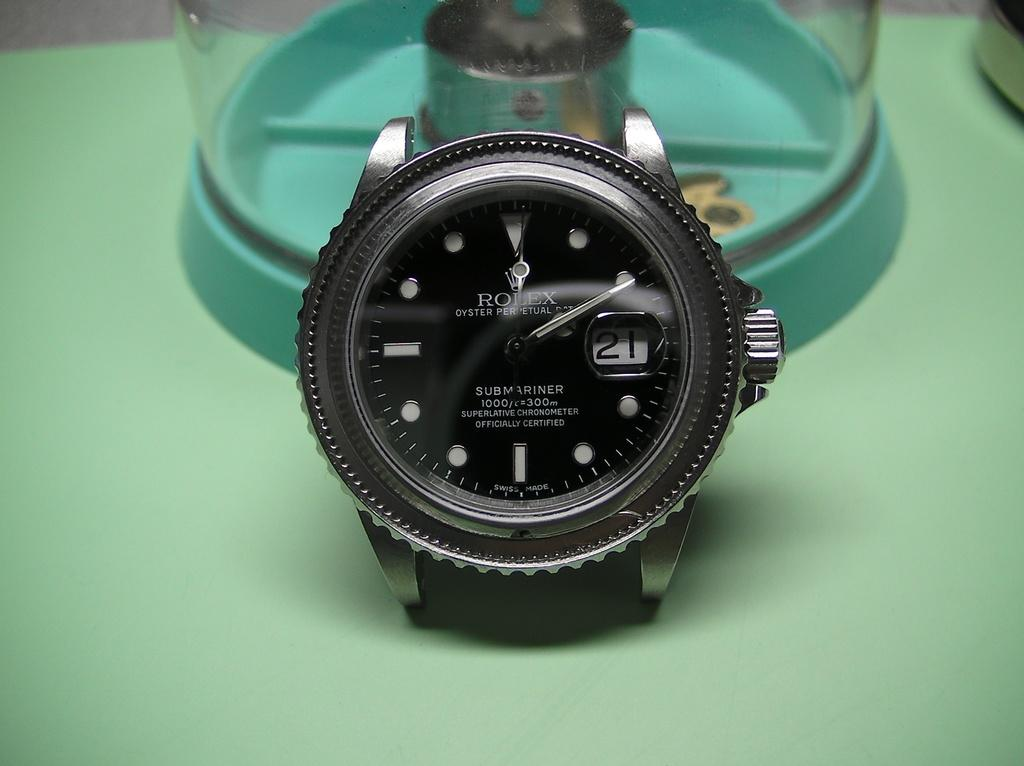<image>
Create a compact narrative representing the image presented. Black watch with the word Rolex on the front. 